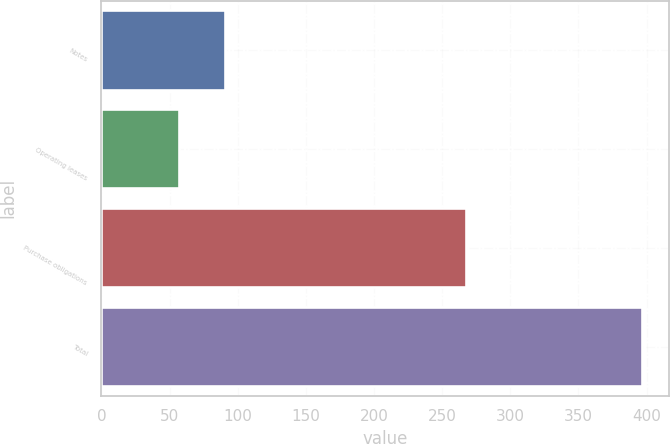Convert chart to OTSL. <chart><loc_0><loc_0><loc_500><loc_500><bar_chart><fcel>Notes<fcel>Operating leases<fcel>Purchase obligations<fcel>Total<nl><fcel>90.75<fcel>56.8<fcel>267.3<fcel>396.3<nl></chart> 